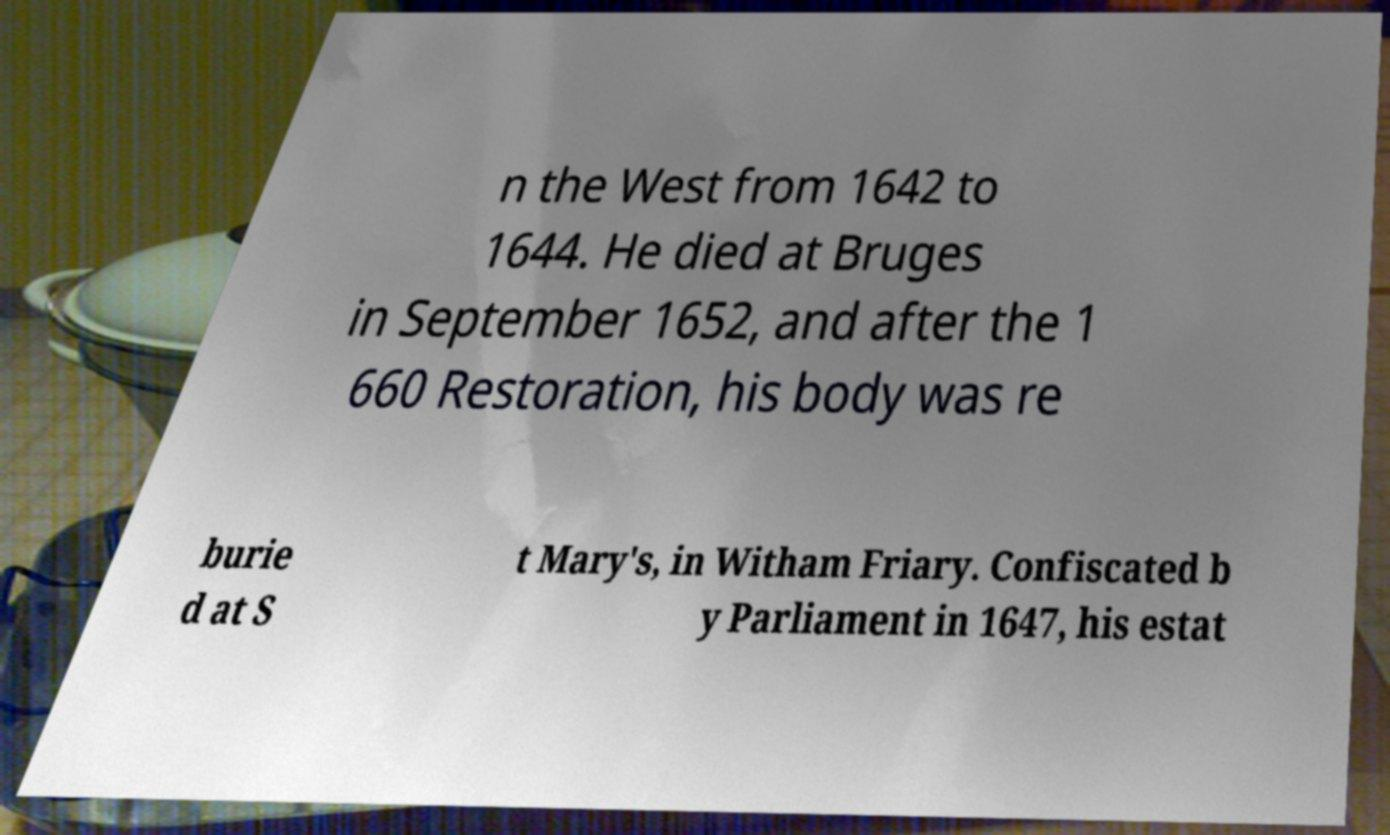Please identify and transcribe the text found in this image. n the West from 1642 to 1644. He died at Bruges in September 1652, and after the 1 660 Restoration, his body was re burie d at S t Mary's, in Witham Friary. Confiscated b y Parliament in 1647, his estat 